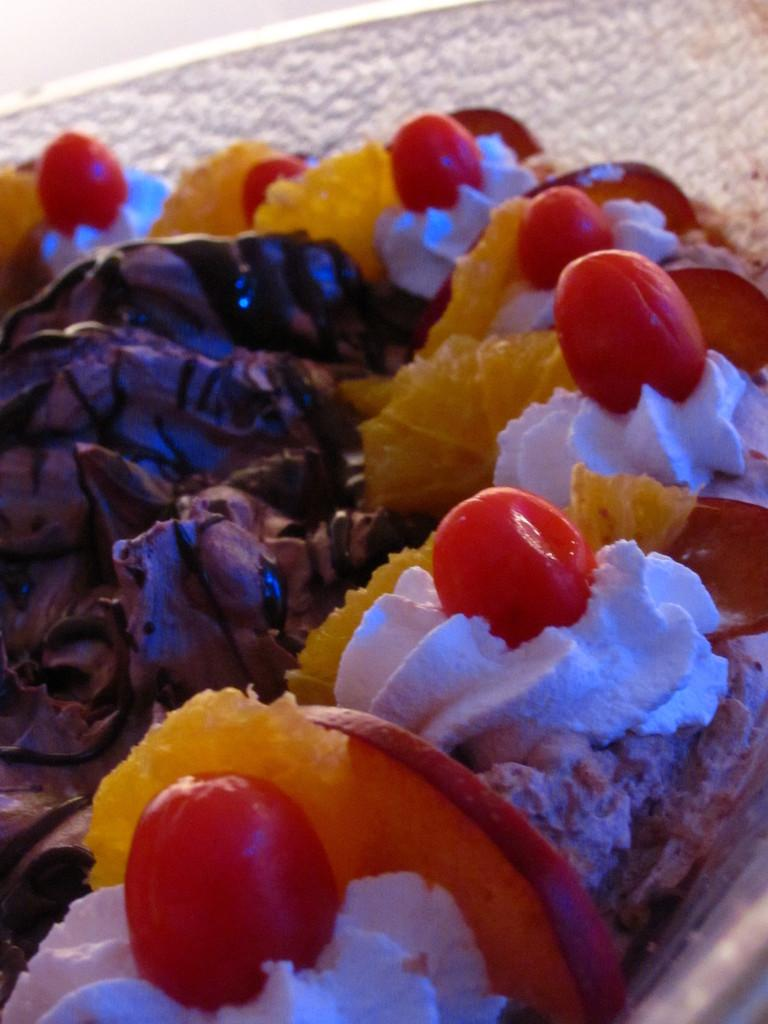What object is present in the image that can hold food? There is a platter in the image that can hold food. What type of food is on the platter? The platter contains a food item that appears to be a cake. Can you describe the cake on the platter? Unfortunately, the image does not provide enough detail to describe the cake. What type of lace can be seen on the cake in the image? There is no lace visible on the cake in the image. Can you tell me how many parents are present in the image? There are no people, including parents, present in the image. 